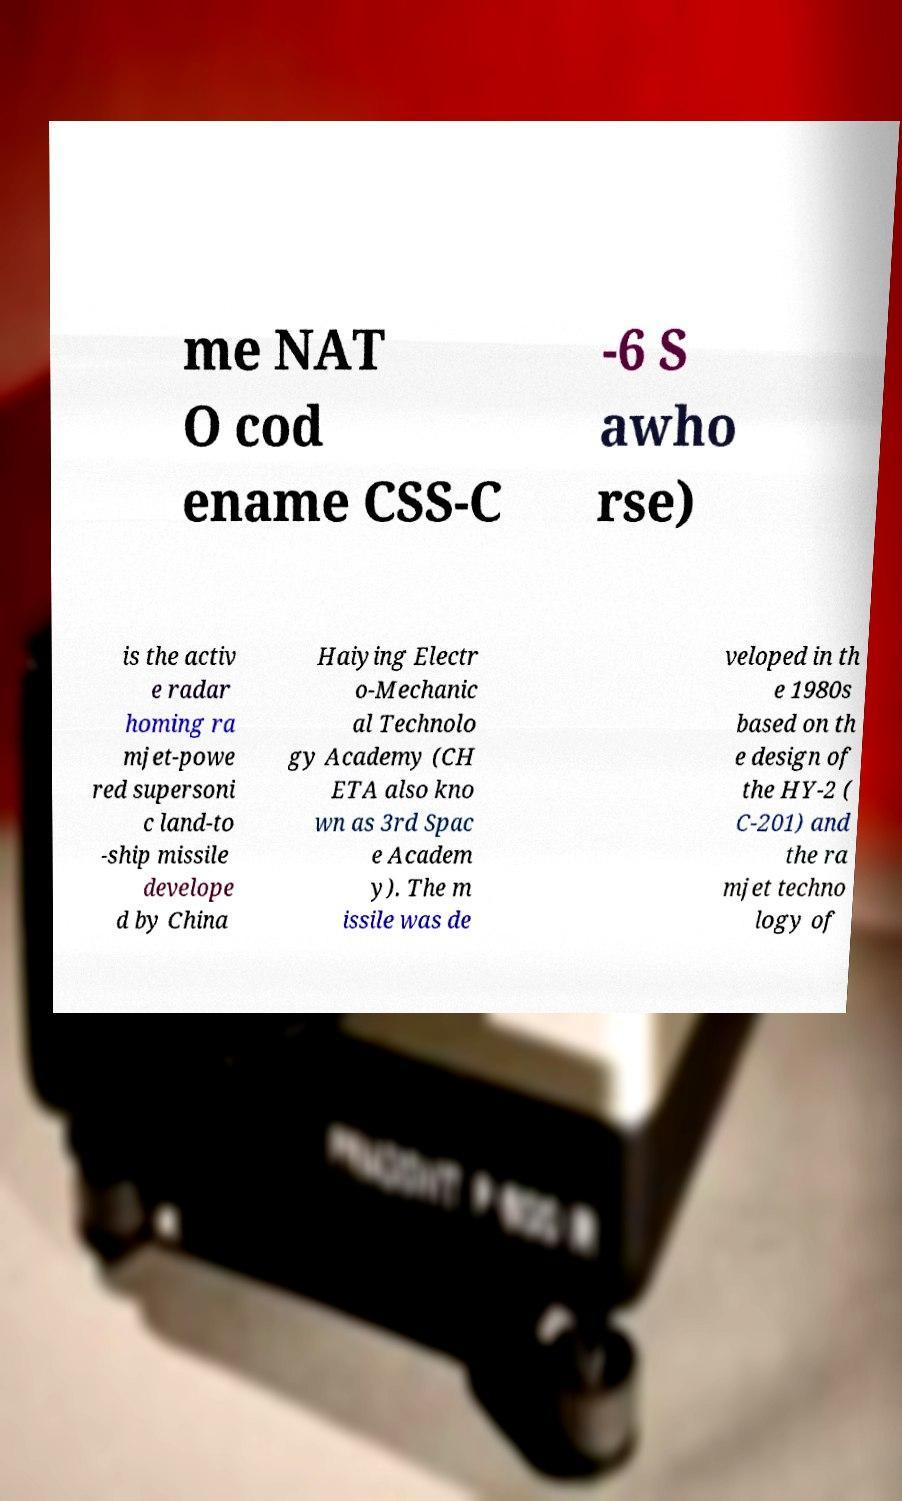Could you extract and type out the text from this image? me NAT O cod ename CSS-C -6 S awho rse) is the activ e radar homing ra mjet-powe red supersoni c land-to -ship missile develope d by China Haiying Electr o-Mechanic al Technolo gy Academy (CH ETA also kno wn as 3rd Spac e Academ y). The m issile was de veloped in th e 1980s based on th e design of the HY-2 ( C-201) and the ra mjet techno logy of 